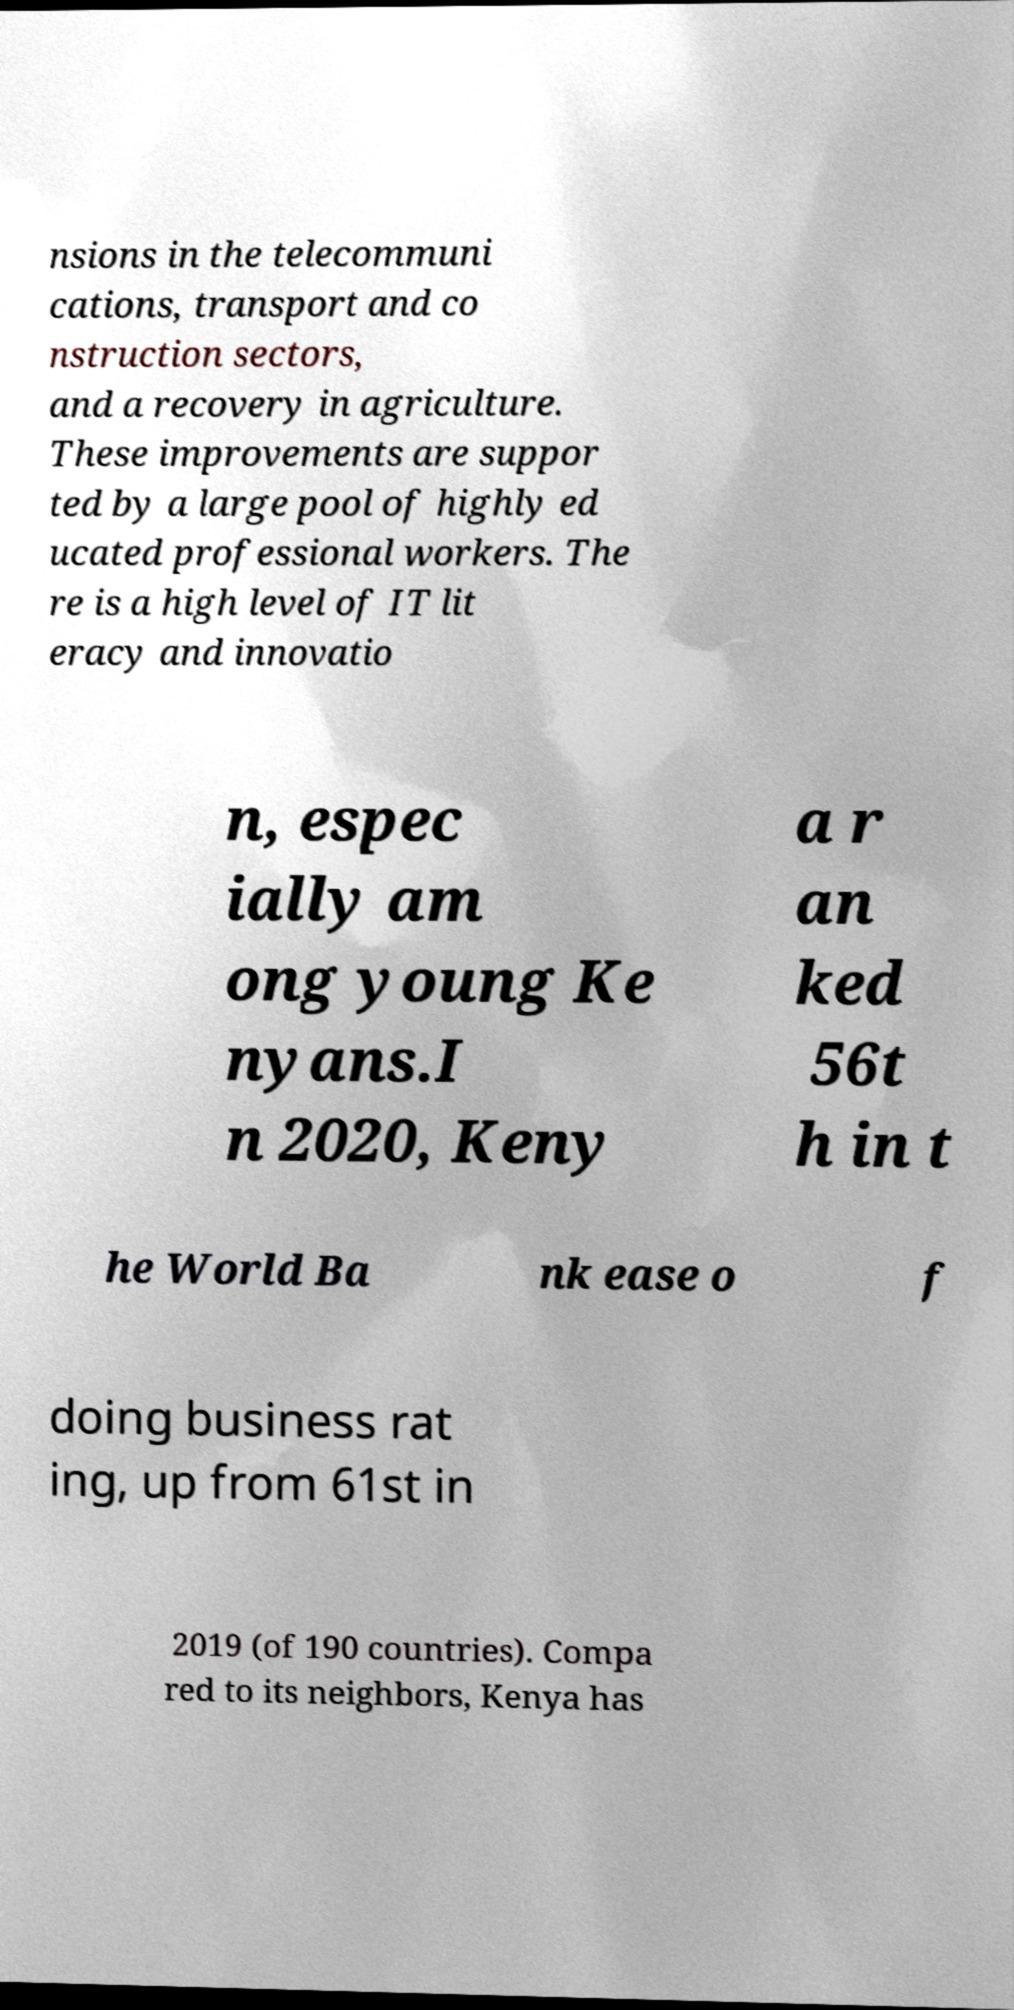There's text embedded in this image that I need extracted. Can you transcribe it verbatim? nsions in the telecommuni cations, transport and co nstruction sectors, and a recovery in agriculture. These improvements are suppor ted by a large pool of highly ed ucated professional workers. The re is a high level of IT lit eracy and innovatio n, espec ially am ong young Ke nyans.I n 2020, Keny a r an ked 56t h in t he World Ba nk ease o f doing business rat ing, up from 61st in 2019 (of 190 countries). Compa red to its neighbors, Kenya has 